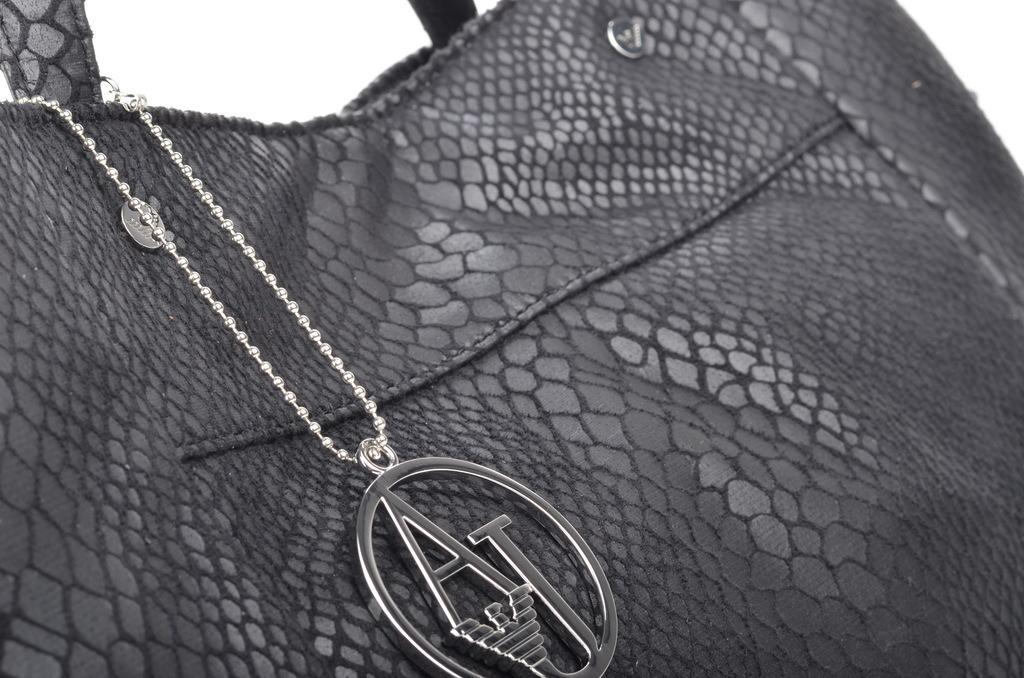Please provide a concise description of this image. We can see black color bag attached with chain. 